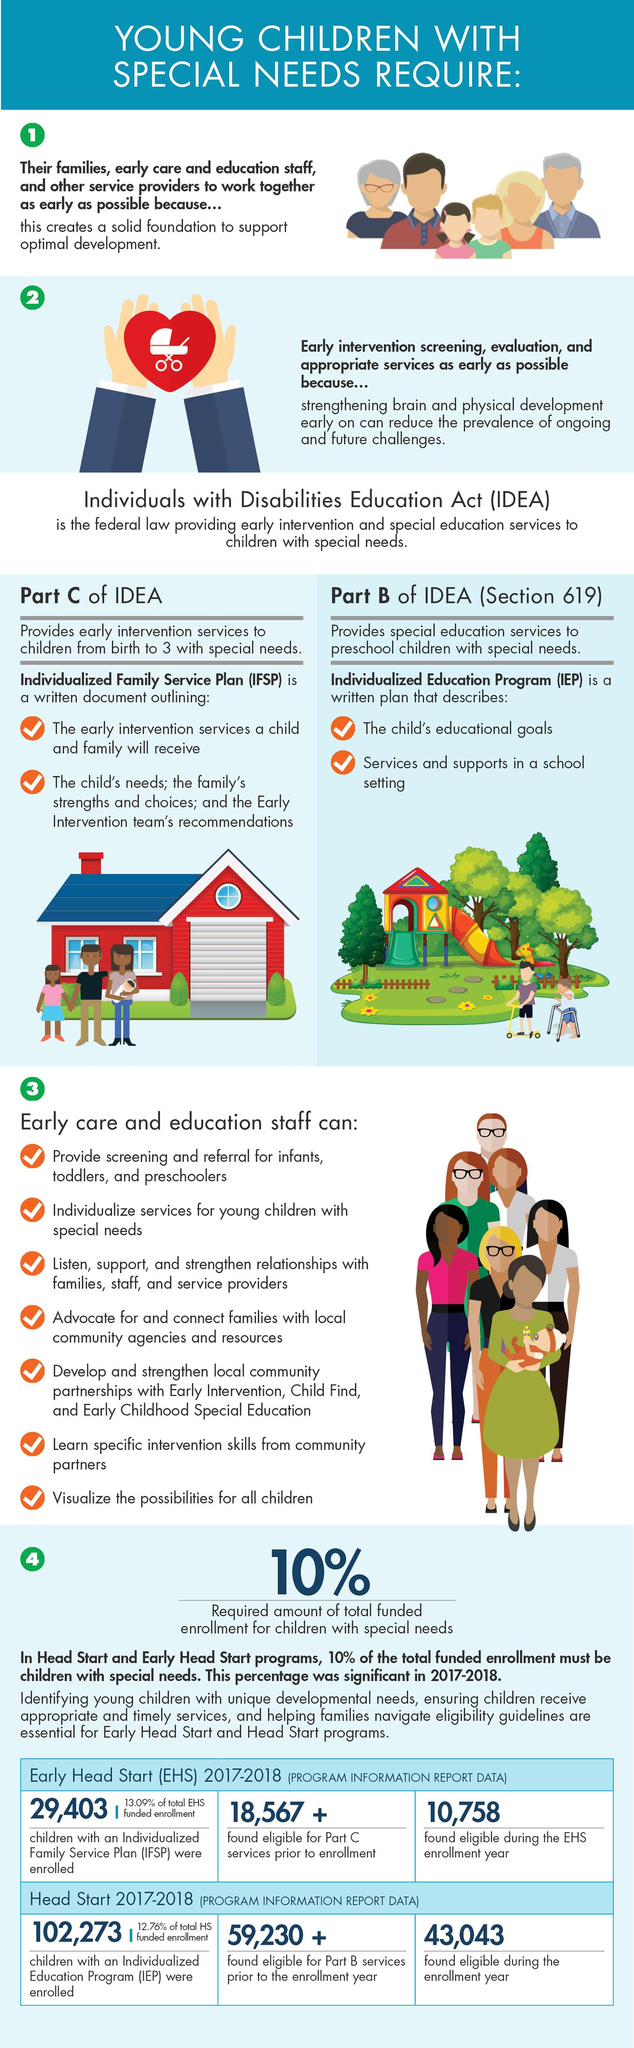Identify some key points in this picture. During the EHS enrollment year, 10,758 children were found to be eligible for services. In the 2017-2018 enrollment year, a total of 59,230 children were found eligible for Part B services in the Head Start Program. During the Head Start enrollment year, a total of 43,043 children were found to be eligible. Prior to the enrollment year in EHS 2017-18, a total of 18,567 children were found eligible for Part C services. 